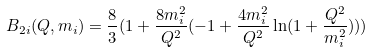<formula> <loc_0><loc_0><loc_500><loc_500>B _ { 2 i } ( Q , m _ { i } ) = \frac { 8 } { 3 } ( 1 + \frac { 8 m _ { i } ^ { 2 } } { Q ^ { 2 } } ( - 1 + \frac { 4 m _ { i } ^ { 2 } } { Q ^ { 2 } } \ln ( 1 + \frac { Q ^ { 2 } } { m _ { i } ^ { 2 } } ) ) )</formula> 